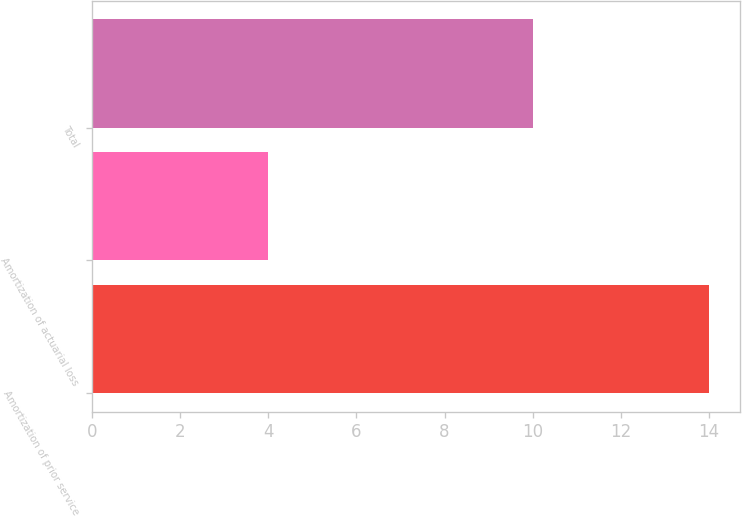Convert chart to OTSL. <chart><loc_0><loc_0><loc_500><loc_500><bar_chart><fcel>Amortization of prior service<fcel>Amortization of actuarial loss<fcel>Total<nl><fcel>14<fcel>4<fcel>10<nl></chart> 